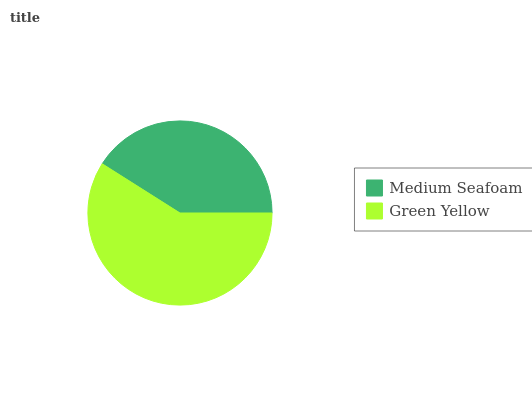Is Medium Seafoam the minimum?
Answer yes or no. Yes. Is Green Yellow the maximum?
Answer yes or no. Yes. Is Green Yellow the minimum?
Answer yes or no. No. Is Green Yellow greater than Medium Seafoam?
Answer yes or no. Yes. Is Medium Seafoam less than Green Yellow?
Answer yes or no. Yes. Is Medium Seafoam greater than Green Yellow?
Answer yes or no. No. Is Green Yellow less than Medium Seafoam?
Answer yes or no. No. Is Green Yellow the high median?
Answer yes or no. Yes. Is Medium Seafoam the low median?
Answer yes or no. Yes. Is Medium Seafoam the high median?
Answer yes or no. No. Is Green Yellow the low median?
Answer yes or no. No. 